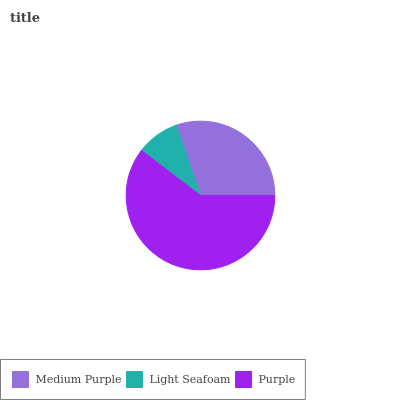Is Light Seafoam the minimum?
Answer yes or no. Yes. Is Purple the maximum?
Answer yes or no. Yes. Is Purple the minimum?
Answer yes or no. No. Is Light Seafoam the maximum?
Answer yes or no. No. Is Purple greater than Light Seafoam?
Answer yes or no. Yes. Is Light Seafoam less than Purple?
Answer yes or no. Yes. Is Light Seafoam greater than Purple?
Answer yes or no. No. Is Purple less than Light Seafoam?
Answer yes or no. No. Is Medium Purple the high median?
Answer yes or no. Yes. Is Medium Purple the low median?
Answer yes or no. Yes. Is Purple the high median?
Answer yes or no. No. Is Purple the low median?
Answer yes or no. No. 